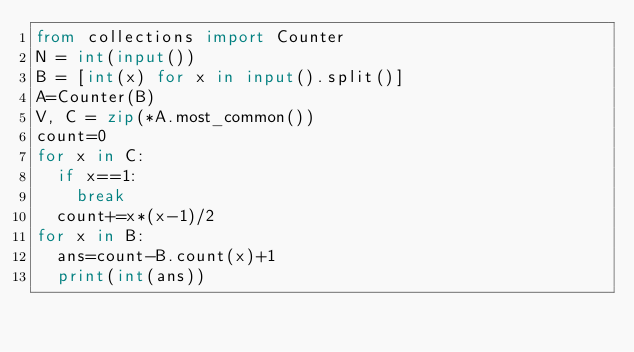<code> <loc_0><loc_0><loc_500><loc_500><_Python_>from collections import Counter
N = int(input())
B = [int(x) for x in input().split()]
A=Counter(B)
V, C = zip(*A.most_common())
count=0
for x in C:
  if x==1:
    break
  count+=x*(x-1)/2
for x in B:
  ans=count-B.count(x)+1
  print(int(ans))</code> 